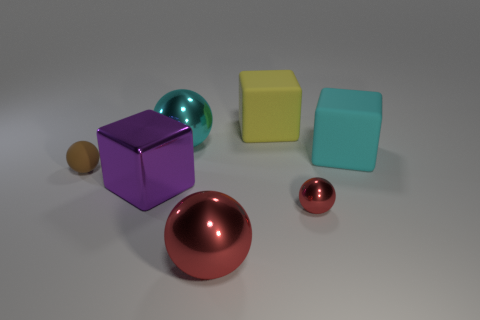There is another tiny thing that is the same shape as the tiny brown matte thing; what color is it?
Your answer should be compact. Red. There is another metallic object that is the same color as the small metal thing; what shape is it?
Offer a very short reply. Sphere. There is a thing that is the same color as the small metal ball; what is its size?
Offer a terse response. Large. Is the number of small metal objects greater than the number of objects?
Give a very brief answer. No. There is a tiny ball left of the small metallic ball; what is its color?
Your response must be concise. Brown. Are there more red metallic balls behind the yellow matte block than tiny purple shiny things?
Offer a terse response. No. Is the cyan block made of the same material as the big yellow object?
Give a very brief answer. Yes. What number of other objects are the same shape as the big purple thing?
Give a very brief answer. 2. Is there any other thing that has the same material as the cyan ball?
Keep it short and to the point. Yes. What is the color of the matte block that is on the right side of the tiny object right of the metallic ball behind the large cyan cube?
Give a very brief answer. Cyan. 